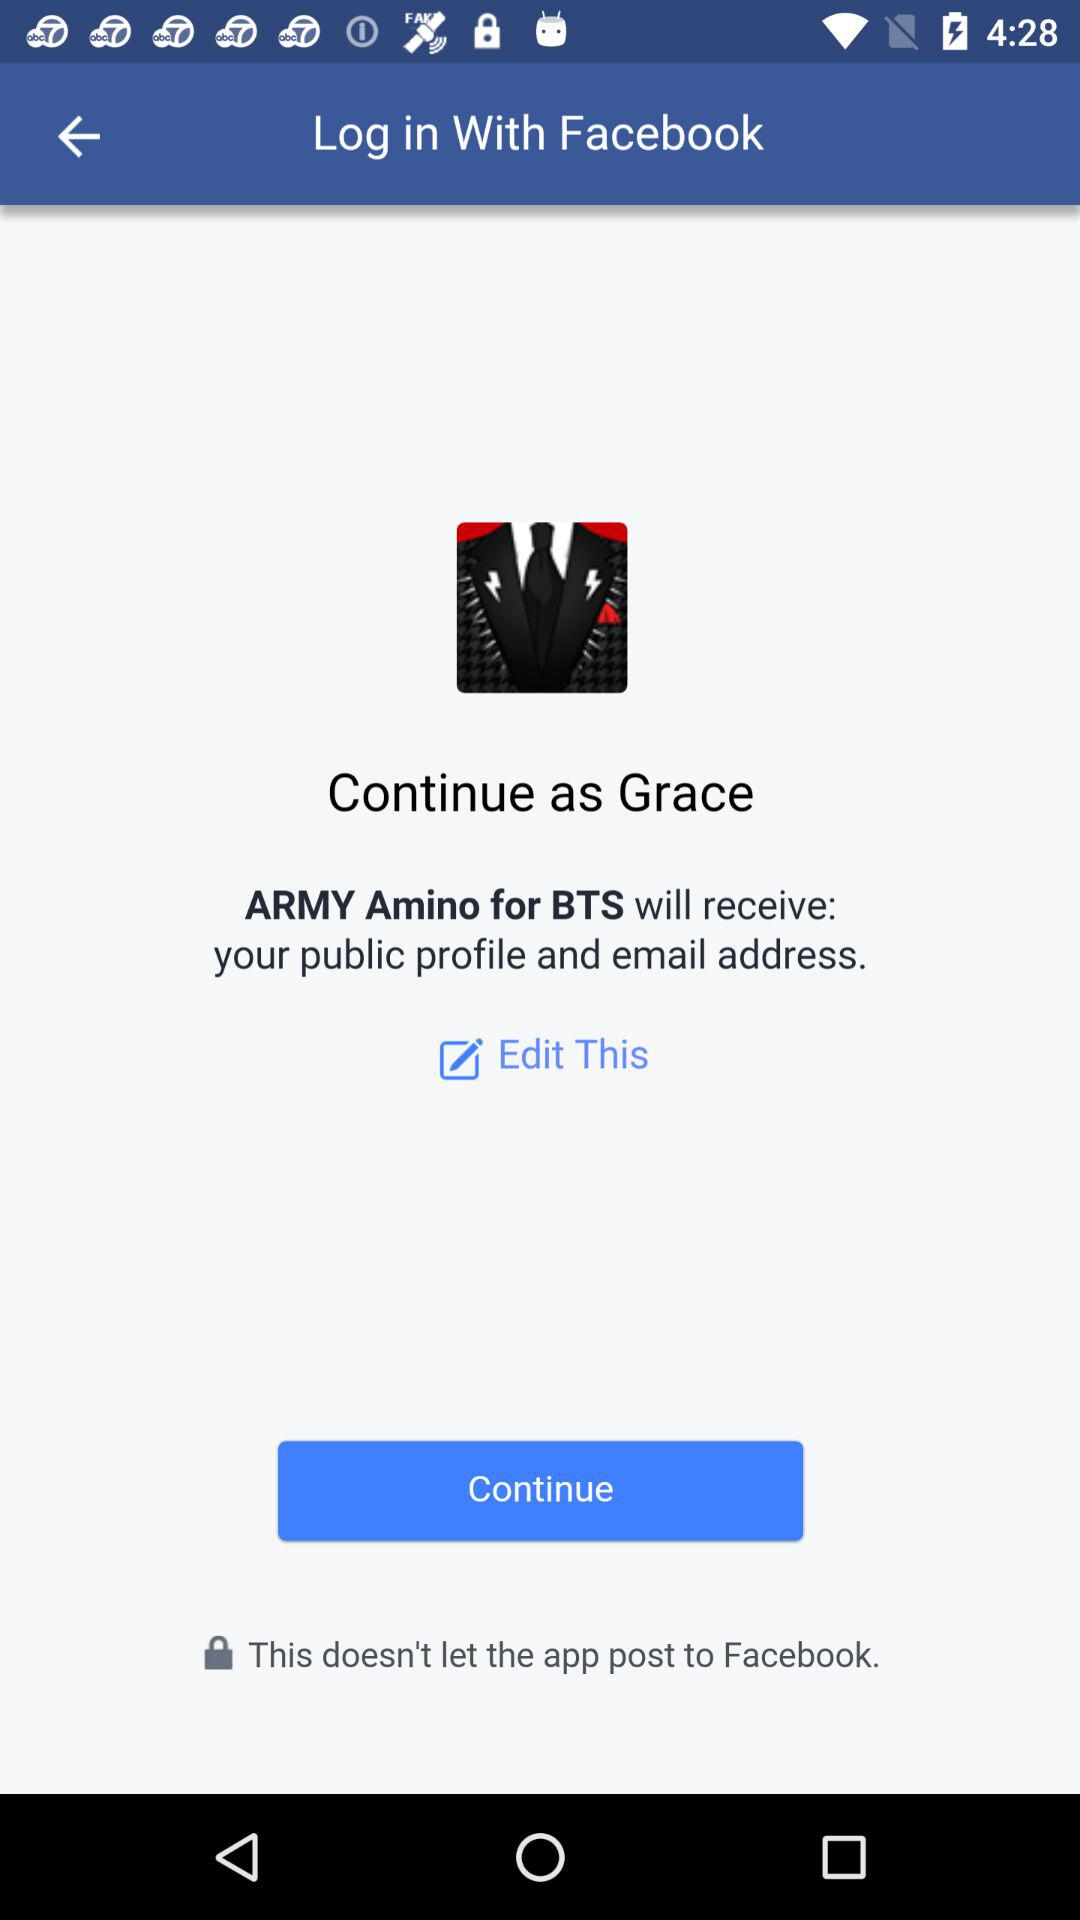What is the name of the user? The name of the user is Grace. 